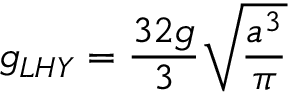<formula> <loc_0><loc_0><loc_500><loc_500>g _ { L H Y } = \frac { 3 2 g } { 3 } \sqrt { \frac { a ^ { 3 } } { \pi } }</formula> 